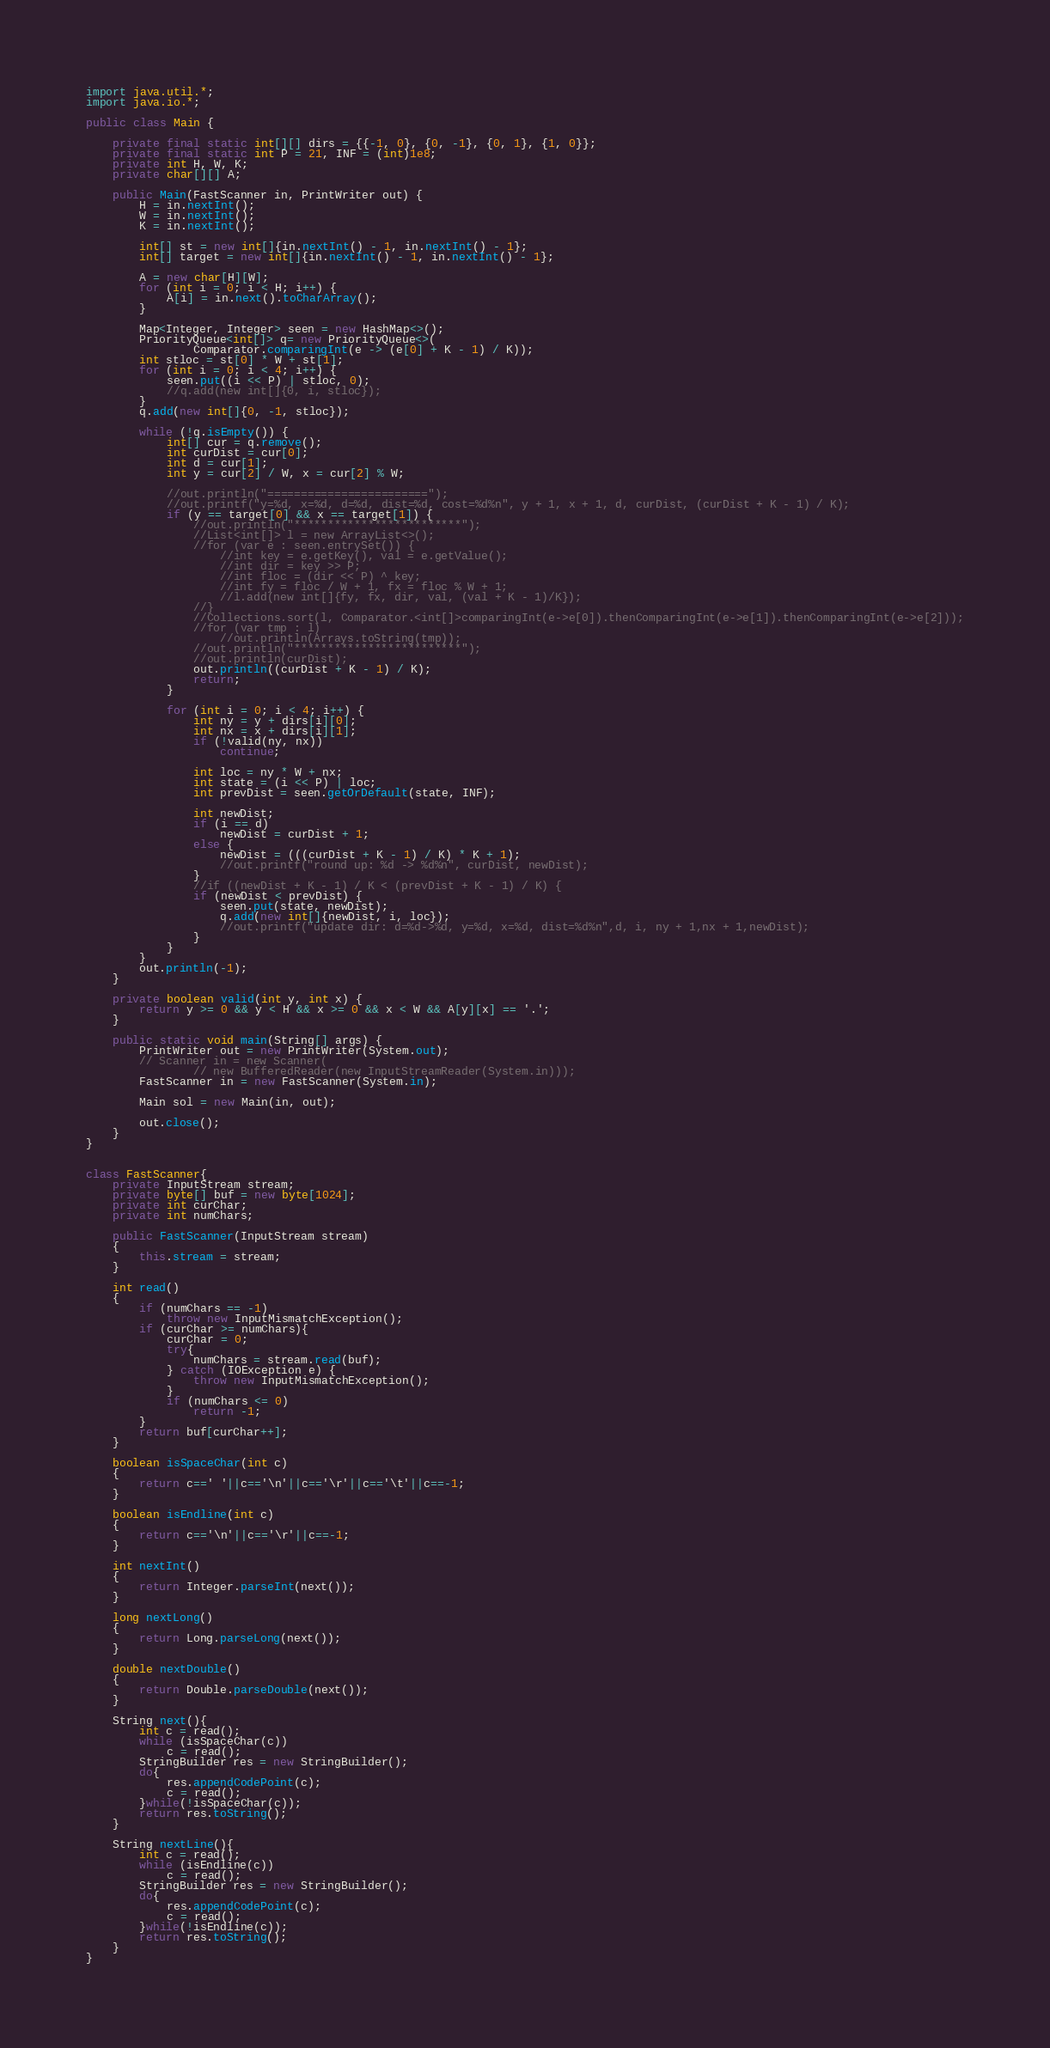Convert code to text. <code><loc_0><loc_0><loc_500><loc_500><_Java_>import java.util.*;
import java.io.*;

public class Main {

    private final static int[][] dirs = {{-1, 0}, {0, -1}, {0, 1}, {1, 0}};
    private final static int P = 21, INF = (int)1e8;
    private int H, W, K;
    private char[][] A;

    public Main(FastScanner in, PrintWriter out) {
        H = in.nextInt();
        W = in.nextInt();
        K = in.nextInt();

        int[] st = new int[]{in.nextInt() - 1, in.nextInt() - 1};
        int[] target = new int[]{in.nextInt() - 1, in.nextInt() - 1};

        A = new char[H][W];
        for (int i = 0; i < H; i++) {
            A[i] = in.next().toCharArray();
        }

        Map<Integer, Integer> seen = new HashMap<>();
        PriorityQueue<int[]> q= new PriorityQueue<>(
                Comparator.comparingInt(e -> (e[0] + K - 1) / K));
        int stloc = st[0] * W + st[1];
        for (int i = 0; i < 4; i++) {
            seen.put((i << P) | stloc, 0);
            //q.add(new int[]{0, i, stloc});
        }
        q.add(new int[]{0, -1, stloc});

        while (!q.isEmpty()) {
            int[] cur = q.remove();
            int curDist = cur[0];
            int d = cur[1];
            int y = cur[2] / W, x = cur[2] % W;

            //out.println("========================");
            //out.printf("y=%d, x=%d, d=%d, dist=%d, cost=%d%n", y + 1, x + 1, d, curDist, (curDist + K - 1) / K);
            if (y == target[0] && x == target[1]) {
                //out.println("*************************");
                //List<int[]> l = new ArrayList<>();
                //for (var e : seen.entrySet()) {
                    //int key = e.getKey(), val = e.getValue();
                    //int dir = key >> P;
                    //int floc = (dir << P) ^ key;
                    //int fy = floc / W + 1, fx = floc % W + 1;
                    //l.add(new int[]{fy, fx, dir, val, (val + K - 1)/K});
                //}
                //Collections.sort(l, Comparator.<int[]>comparingInt(e->e[0]).thenComparingInt(e->e[1]).thenComparingInt(e->e[2]));
                //for (var tmp : l)
                    //out.println(Arrays.toString(tmp));
                //out.println("*************************");
                //out.println(curDist);
                out.println((curDist + K - 1) / K);
                return;
            }

            for (int i = 0; i < 4; i++) {
                int ny = y + dirs[i][0];
                int nx = x + dirs[i][1];
                if (!valid(ny, nx))
                    continue;

                int loc = ny * W + nx;
                int state = (i << P) | loc;
                int prevDist = seen.getOrDefault(state, INF);

                int newDist;
                if (i == d)
                    newDist = curDist + 1;
                else {
                    newDist = (((curDist + K - 1) / K) * K + 1);
                    //out.printf("round up: %d -> %d%n", curDist, newDist);
                }
                //if ((newDist + K - 1) / K < (prevDist + K - 1) / K) {
                if (newDist < prevDist) {
                    seen.put(state, newDist);
                    q.add(new int[]{newDist, i, loc});
                    //out.printf("update dir: d=%d->%d, y=%d, x=%d, dist=%d%n",d, i, ny + 1,nx + 1,newDist);
                }
            }
        }
        out.println(-1);
    }

    private boolean valid(int y, int x) {
        return y >= 0 && y < H && x >= 0 && x < W && A[y][x] == '.';
    }

    public static void main(String[] args) {
        PrintWriter out = new PrintWriter(System.out);
        // Scanner in = new Scanner(
                // new BufferedReader(new InputStreamReader(System.in)));
        FastScanner in = new FastScanner(System.in);

        Main sol = new Main(in, out);

        out.close();
    }
}


class FastScanner{
    private InputStream stream;
    private byte[] buf = new byte[1024];
    private int curChar;
    private int numChars;

    public FastScanner(InputStream stream)
    {
        this.stream = stream;
    }

    int read()
    {
        if (numChars == -1)
            throw new InputMismatchException();
        if (curChar >= numChars){
            curChar = 0;
            try{
                numChars = stream.read(buf);
            } catch (IOException e) {
                throw new InputMismatchException();
            }
            if (numChars <= 0)
                return -1;
        }
        return buf[curChar++];
    }

    boolean isSpaceChar(int c)
    {
        return c==' '||c=='\n'||c=='\r'||c=='\t'||c==-1;
    }

    boolean isEndline(int c)
    {
        return c=='\n'||c=='\r'||c==-1;
    }

    int nextInt()
    {
        return Integer.parseInt(next());
    }

    long nextLong()
    {
        return Long.parseLong(next());
    }

    double nextDouble()
    {
        return Double.parseDouble(next());
    }

    String next(){
        int c = read();
        while (isSpaceChar(c))
            c = read();
        StringBuilder res = new StringBuilder();
        do{
            res.appendCodePoint(c);
            c = read();
        }while(!isSpaceChar(c));
        return res.toString();
    }

    String nextLine(){
        int c = read();
        while (isEndline(c))
            c = read();
        StringBuilder res = new StringBuilder();
        do{
            res.appendCodePoint(c);
            c = read();
        }while(!isEndline(c));
        return res.toString();
    }
}
</code> 